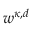Convert formula to latex. <formula><loc_0><loc_0><loc_500><loc_500>w ^ { \kappa , d }</formula> 